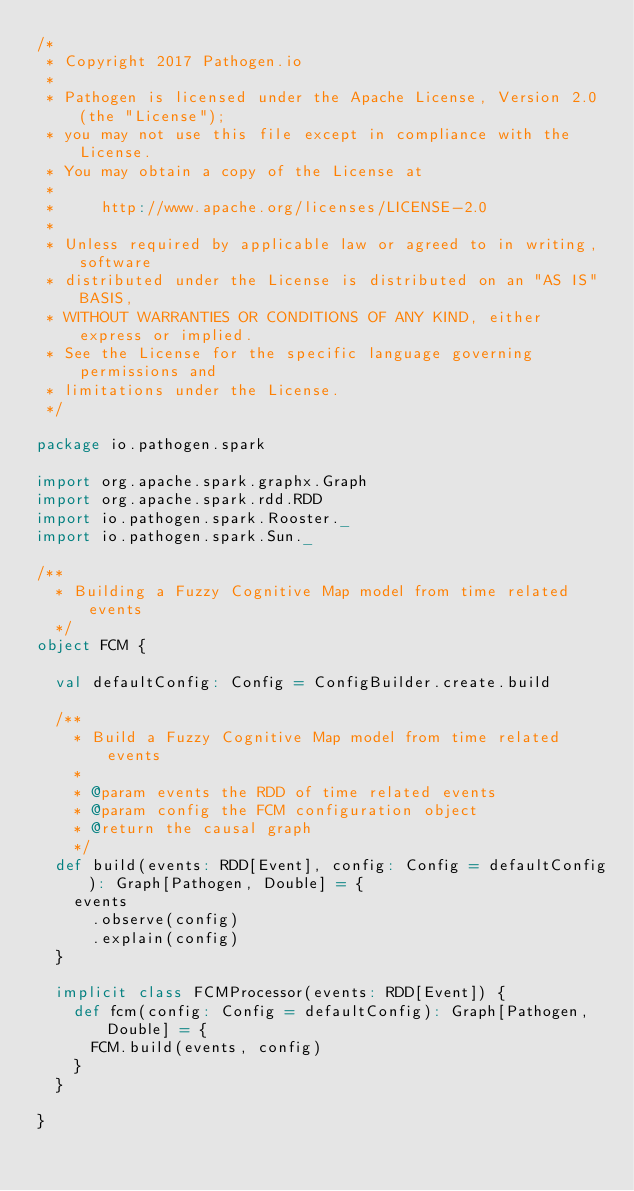<code> <loc_0><loc_0><loc_500><loc_500><_Scala_>/*
 * Copyright 2017 Pathogen.io
 *
 * Pathogen is licensed under the Apache License, Version 2.0 (the "License");
 * you may not use this file except in compliance with the License.
 * You may obtain a copy of the License at
 *
 *     http://www.apache.org/licenses/LICENSE-2.0
 *
 * Unless required by applicable law or agreed to in writing, software
 * distributed under the License is distributed on an "AS IS" BASIS,
 * WITHOUT WARRANTIES OR CONDITIONS OF ANY KIND, either express or implied.
 * See the License for the specific language governing permissions and
 * limitations under the License.
 */

package io.pathogen.spark

import org.apache.spark.graphx.Graph
import org.apache.spark.rdd.RDD
import io.pathogen.spark.Rooster._
import io.pathogen.spark.Sun._

/**
  * Building a Fuzzy Cognitive Map model from time related events
  */
object FCM {

  val defaultConfig: Config = ConfigBuilder.create.build

  /**
    * Build a Fuzzy Cognitive Map model from time related events
    *
    * @param events the RDD of time related events
    * @param config the FCM configuration object
    * @return the causal graph
    */
  def build(events: RDD[Event], config: Config = defaultConfig): Graph[Pathogen, Double] = {
    events
      .observe(config)
      .explain(config)
  }

  implicit class FCMProcessor(events: RDD[Event]) {
    def fcm(config: Config = defaultConfig): Graph[Pathogen, Double] = {
      FCM.build(events, config)
    }
  }

}
</code> 